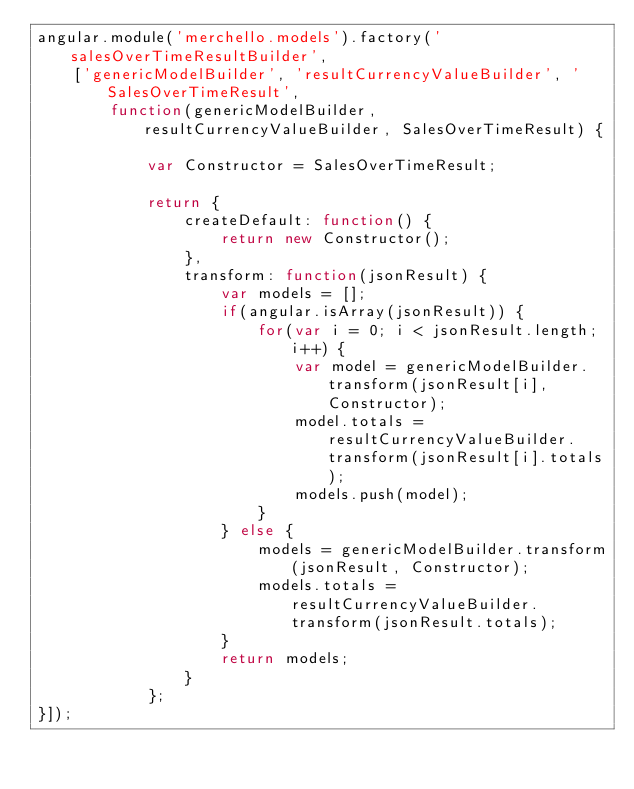Convert code to text. <code><loc_0><loc_0><loc_500><loc_500><_JavaScript_>angular.module('merchello.models').factory('salesOverTimeResultBuilder',
    ['genericModelBuilder', 'resultCurrencyValueBuilder', 'SalesOverTimeResult',
        function(genericModelBuilder, resultCurrencyValueBuilder, SalesOverTimeResult) {

            var Constructor = SalesOverTimeResult;

            return {
                createDefault: function() {
                    return new Constructor();
                },
                transform: function(jsonResult) {
                    var models = [];
                    if(angular.isArray(jsonResult)) {
                        for(var i = 0; i < jsonResult.length; i++) {
                            var model = genericModelBuilder.transform(jsonResult[i], Constructor);
                            model.totals = resultCurrencyValueBuilder.transform(jsonResult[i].totals);
                            models.push(model);
                        }
                    } else {
                        models = genericModelBuilder.transform(jsonResult, Constructor);
                        models.totals = resultCurrencyValueBuilder.transform(jsonResult.totals);
                    }
                    return models;
                }
            };
}]);</code> 